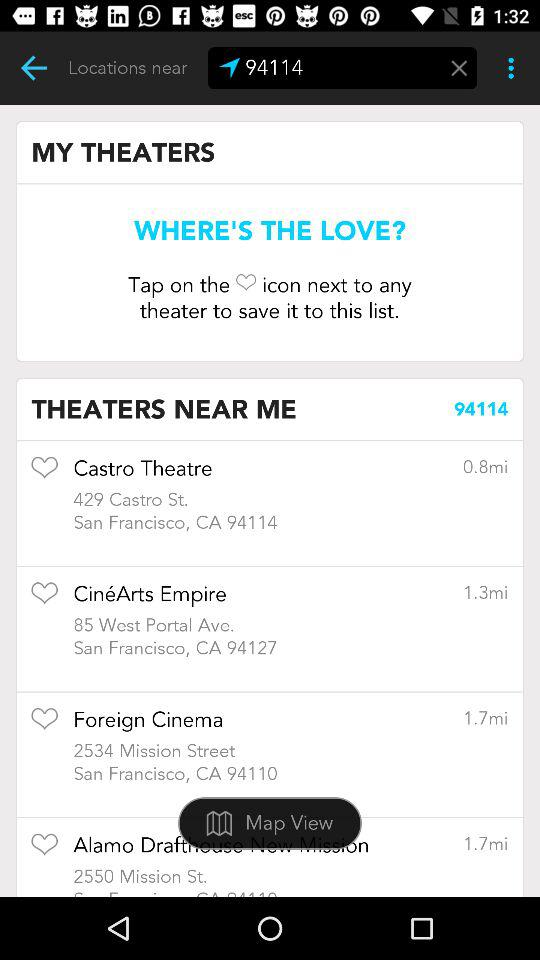How many numbers of Theaters Near me?
When the provided information is insufficient, respond with <no answer>. <no answer> 